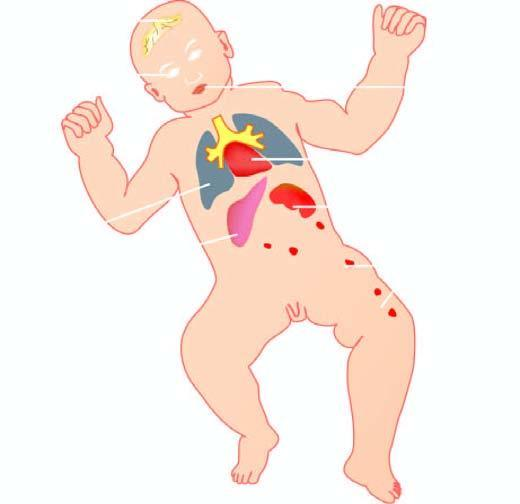how is lesions produced?
Answer the question using a single word or phrase. By torch complex infection in foetus in utero 